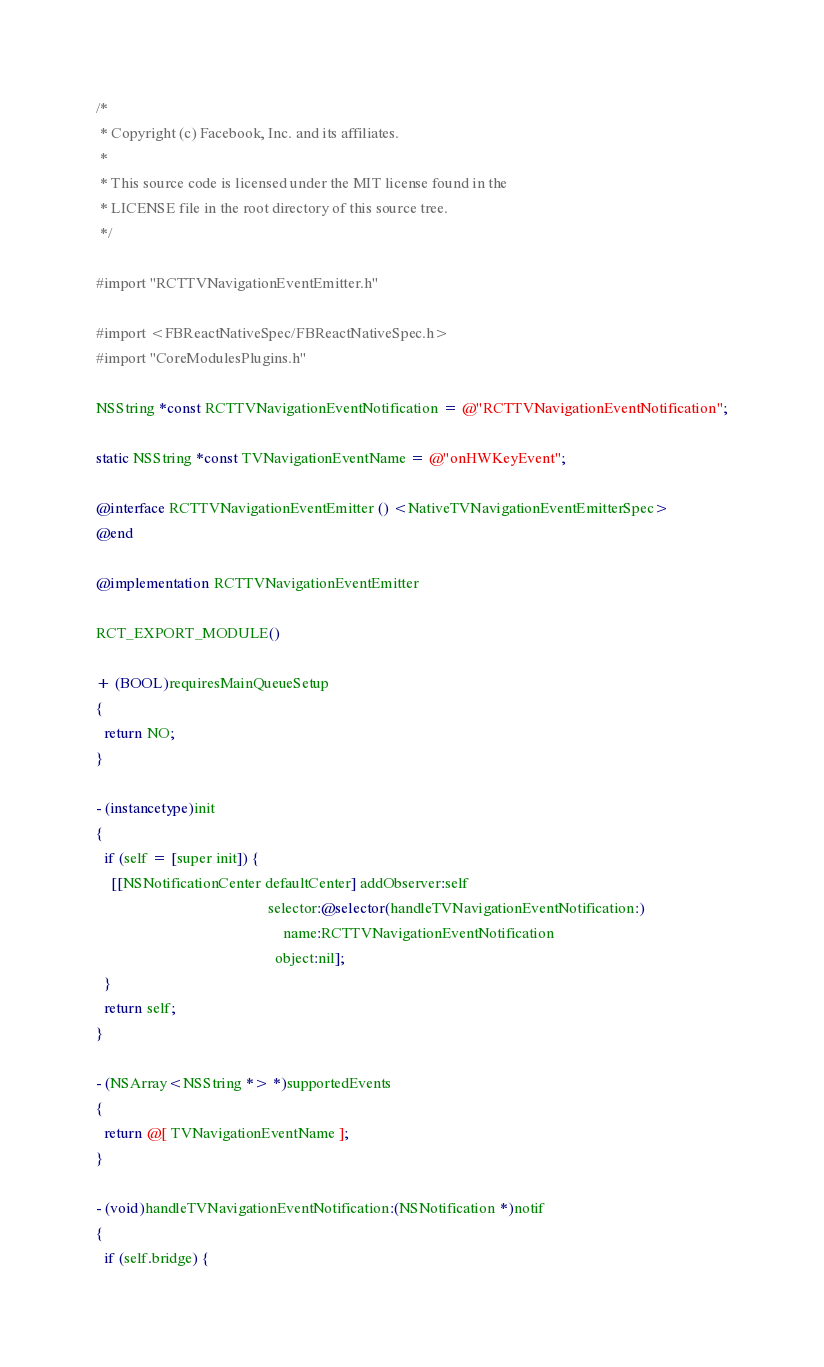<code> <loc_0><loc_0><loc_500><loc_500><_ObjectiveC_>/*
 * Copyright (c) Facebook, Inc. and its affiliates.
 *
 * This source code is licensed under the MIT license found in the
 * LICENSE file in the root directory of this source tree.
 */

#import "RCTTVNavigationEventEmitter.h"

#import <FBReactNativeSpec/FBReactNativeSpec.h>
#import "CoreModulesPlugins.h"

NSString *const RCTTVNavigationEventNotification = @"RCTTVNavigationEventNotification";

static NSString *const TVNavigationEventName = @"onHWKeyEvent";

@interface RCTTVNavigationEventEmitter () <NativeTVNavigationEventEmitterSpec>
@end

@implementation RCTTVNavigationEventEmitter

RCT_EXPORT_MODULE()

+ (BOOL)requiresMainQueueSetup
{
  return NO;
}

- (instancetype)init
{
  if (self = [super init]) {
    [[NSNotificationCenter defaultCenter] addObserver:self
                                             selector:@selector(handleTVNavigationEventNotification:)
                                                 name:RCTTVNavigationEventNotification
                                               object:nil];
  }
  return self;
}

- (NSArray<NSString *> *)supportedEvents
{
  return @[ TVNavigationEventName ];
}

- (void)handleTVNavigationEventNotification:(NSNotification *)notif
{
  if (self.bridge) {</code> 